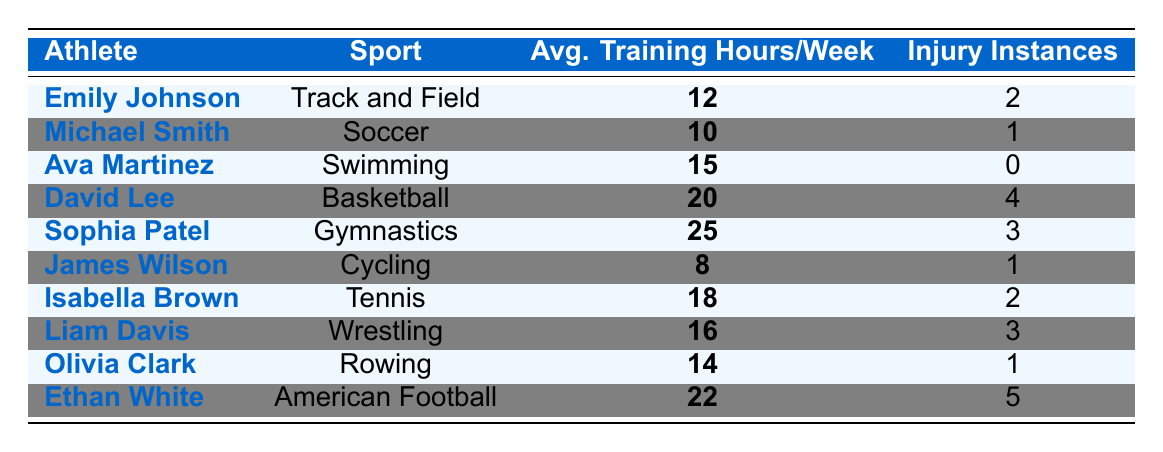What is the average training hours per week for Ethan White? The table shows that Ethan White has an average training value of 22 hours per week, as stated directly in the relevant row.
Answer: 22 How many injury instances did Ava Martinez have? According to the table, Ava Martinez has 0 injury instances listed in her corresponding row.
Answer: 0 Which athlete trained the least per week? By examining the 'Avg. Training Hours/Week' column, James Wilson's training hours of 8 is the lowest compared to the others.
Answer: 8 What is the total number of injury instances for athletes training more than 15 hours per week? The athletes with training hours above 15 are David Lee (4), Sophia Patel (3), Isabella Brown (2), and Ethan White (5). Adding these gives 4 + 3 + 2 + 5 = 14 injury instances.
Answer: 14 Is there any athlete who trained for 25 hours per week? The table lists Sophia Patel, who trained for 25 hours per week, indicating that this fact is true.
Answer: Yes Which sport has the highest reported injury instances? David Lee's sport, Basketball, has 4 injury instances, which is the highest compared to others, confirming it is the sport with the most injuries.
Answer: Basketball What is the difference in injury instances between the athlete with the most training and the athlete with the least training? The athlete with the most training is Sophia Patel with 3 injury instances, and the one with the least is Michael Smith with 1. Thus, the difference is 3 - 1 = 2.
Answer: 2 How many athletes have training hours greater than 15 with fewer than 3 injuries? David Lee (4), Sophia Patel (3), and Ethan White (5) have injuries more than 2. Only Liam Davis (3) does not. Thus, only Isabella Brown (2) meets the criteria for training over 15 and fewer than 3 injuries.
Answer: 1 Are there any athletes who trained for exactly 14 hours per week? The table indicates that Olivia Clark trained for 14 hours, confirming that there is indeed one athlete with this training duration.
Answer: Yes What is the average number of injury instances for all athletes? The total injury instances sum to 18, and the number of athletes is 10. Thus, the average is 18/10 = 1.8 injuries per athlete.
Answer: 1.8 